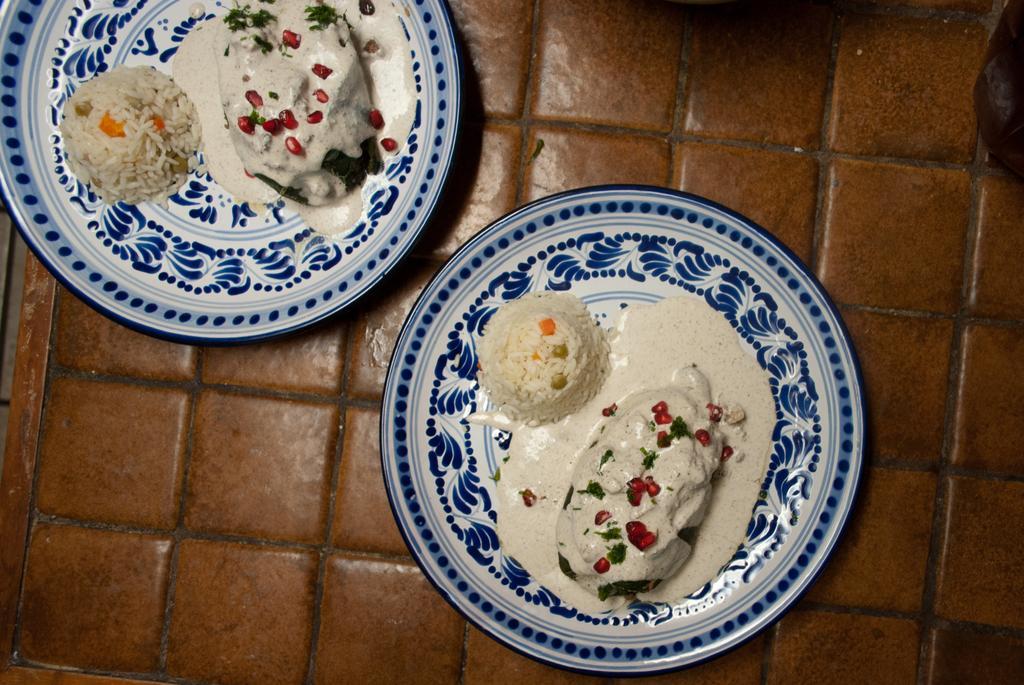In one or two sentences, can you explain what this image depicts? In this image there are two plates on the floor. There is food on the plates. There is a print on the plates. 